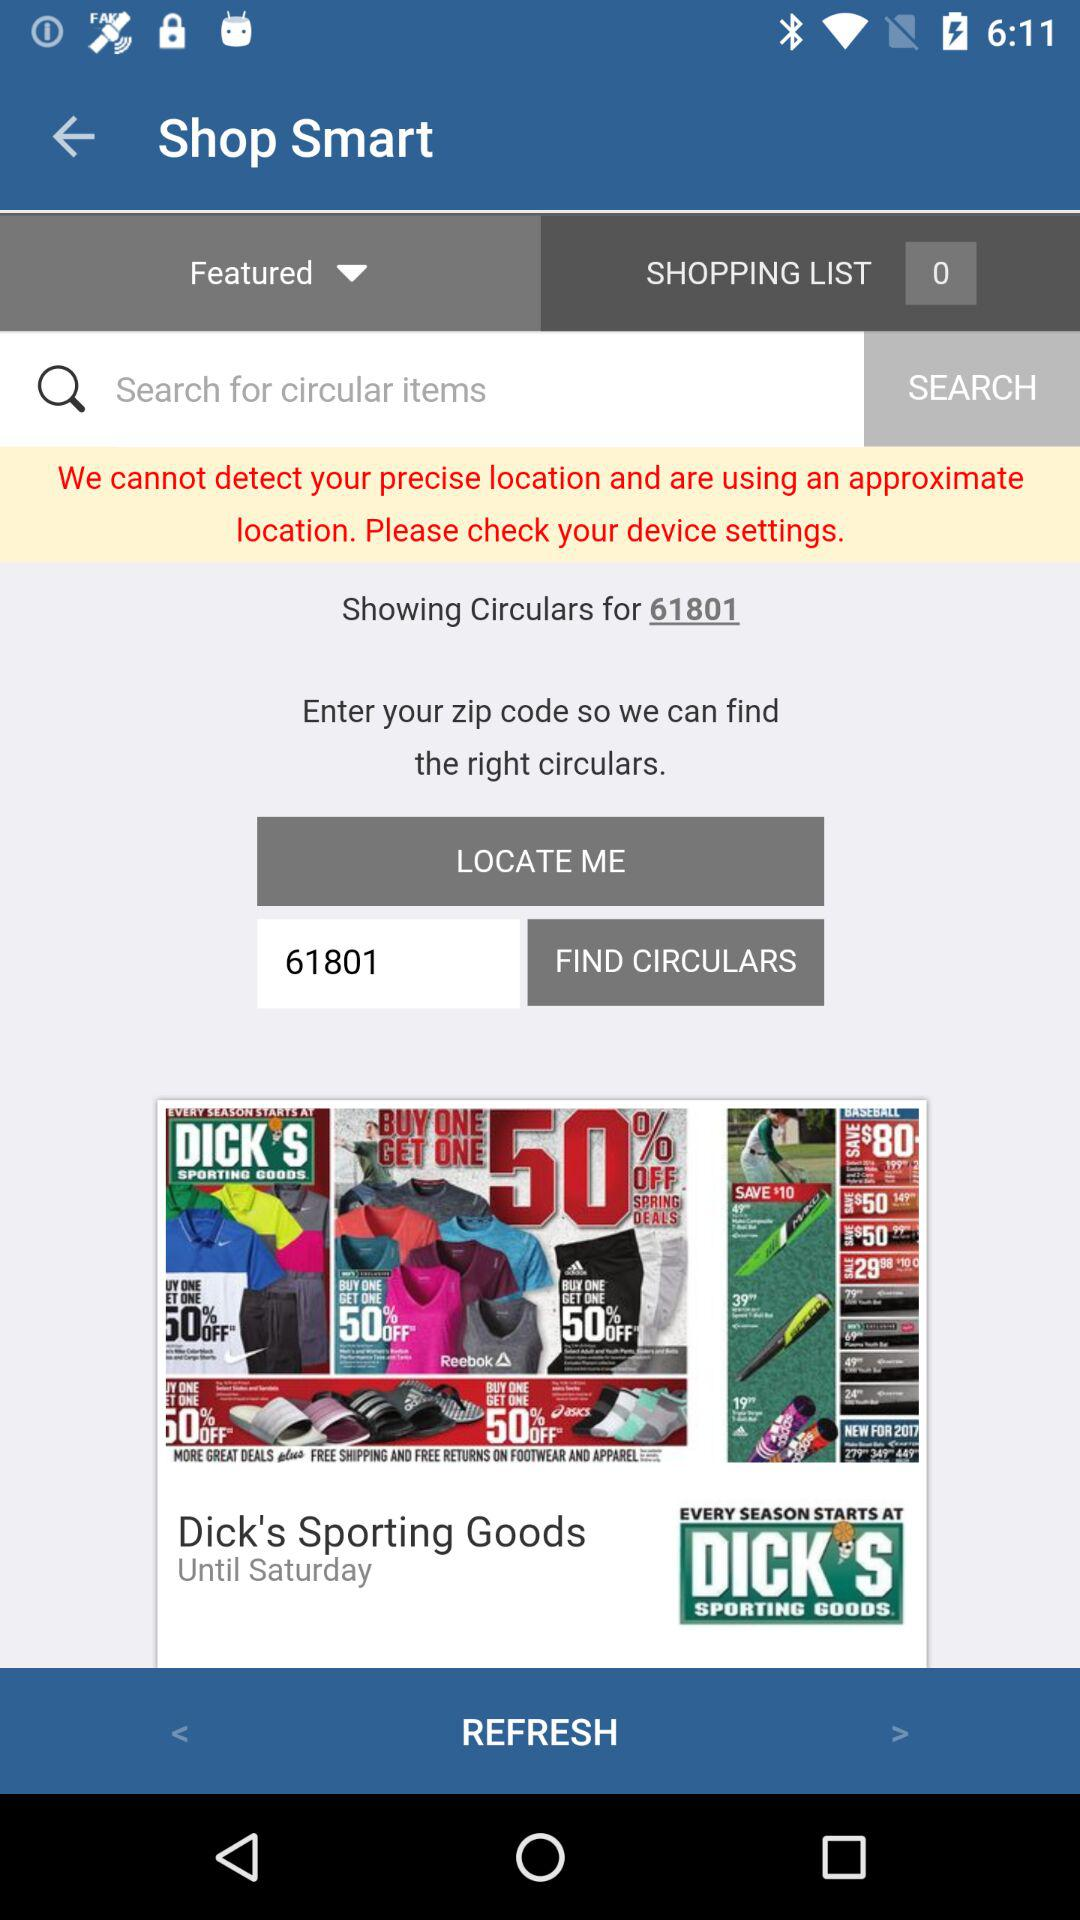How many items are shown in the shopping list? There are 0 items shown in the shopping list. 